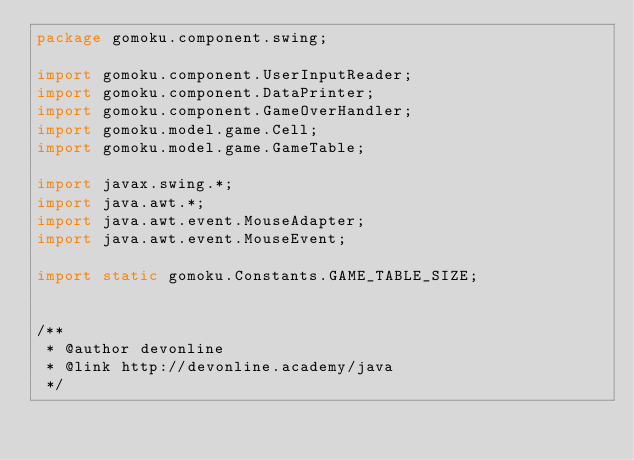Convert code to text. <code><loc_0><loc_0><loc_500><loc_500><_Java_>package gomoku.component.swing;

import gomoku.component.UserInputReader;
import gomoku.component.DataPrinter;
import gomoku.component.GameOverHandler;
import gomoku.model.game.Cell;
import gomoku.model.game.GameTable;

import javax.swing.*;
import java.awt.*;
import java.awt.event.MouseAdapter;
import java.awt.event.MouseEvent;

import static gomoku.Constants.GAME_TABLE_SIZE;


/**
 * @author devonline
 * @link http://devonline.academy/java
 */</code> 